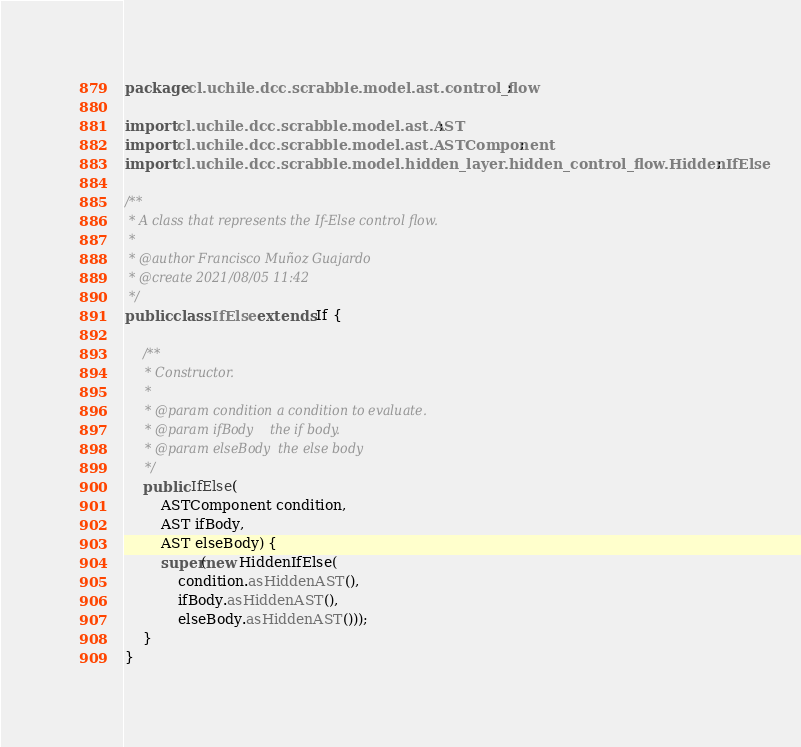<code> <loc_0><loc_0><loc_500><loc_500><_Java_>package cl.uchile.dcc.scrabble.model.ast.control_flow;

import cl.uchile.dcc.scrabble.model.ast.AST;
import cl.uchile.dcc.scrabble.model.ast.ASTComponent;
import cl.uchile.dcc.scrabble.model.hidden_layer.hidden_control_flow.HiddenIfElse;

/**
 * A class that represents the If-Else control flow.
 *
 * @author Francisco Muñoz Guajardo
 * @create 2021/08/05 11:42
 */
public class IfElse extends If {

    /**
     * Constructor.
     *
     * @param condition a condition to evaluate.
     * @param ifBody    the if body.
     * @param elseBody  the else body
     */
    public IfElse(
        ASTComponent condition,
        AST ifBody,
        AST elseBody) {
        super(new HiddenIfElse(
            condition.asHiddenAST(),
            ifBody.asHiddenAST(),
            elseBody.asHiddenAST()));
    }
}
</code> 